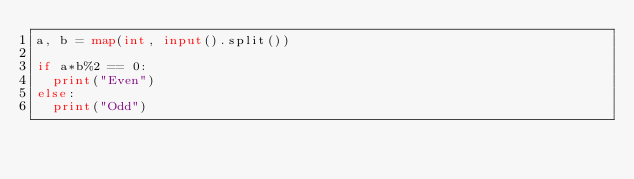<code> <loc_0><loc_0><loc_500><loc_500><_Python_>a, b = map(int, input().split())

if a*b%2 == 0:
  print("Even")
else:
  print("Odd")</code> 